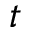<formula> <loc_0><loc_0><loc_500><loc_500>t</formula> 